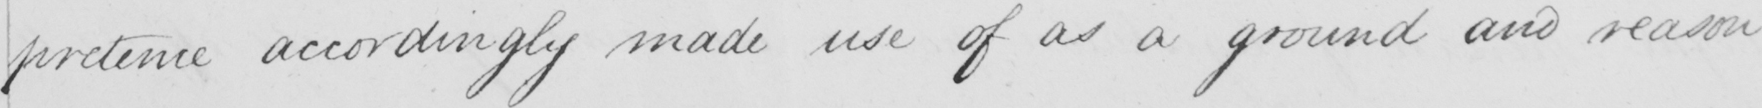What is written in this line of handwriting? pretence accordingly made use of as a ground and reason 